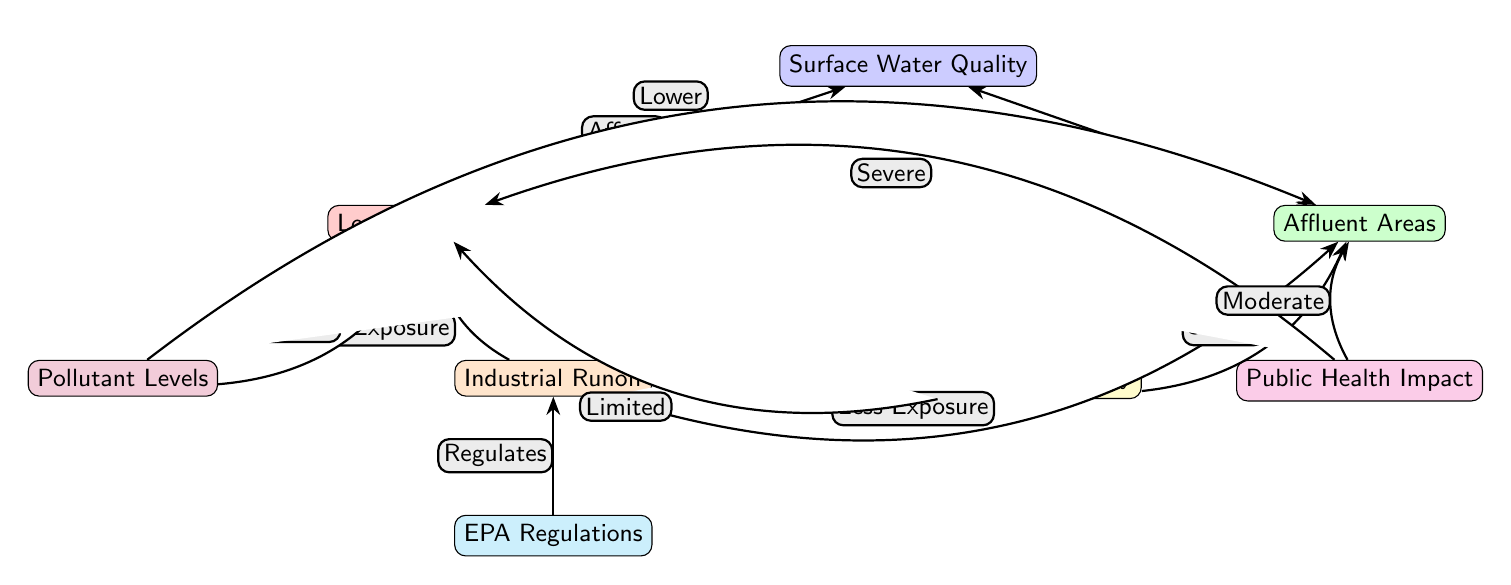What affects surface water quality in low-income areas? The node "Low-Income Areas" has a direct edge labeled "Affects" pointing to "Surface Water Quality". Therefore, it indicates that factors related to low-income areas significantly influence the quality of surface water.
Answer: Low-Income Areas What is the public health impact in affluent areas? The node "Public Health Impact" has an edge leading from "Affluent Areas". The label indicates that the impact is moderate in affluent areas, as represented in the flow of the diagram.
Answer: Moderate How many nodes are there in the diagram? Counting all the distinct labeled nodes in the diagram including "Surface Water Quality," "Low-Income Areas," "Affluent Areas," "Industrial Runoff," "Pollutant Levels," "Community Advocacy," "EPA Regulations," and "Public Health Impact" gives a total of 8 nodes.
Answer: 8 What is the relationship between industrial runoff and low-income areas? The edge between "Industrial Runoff" and "Low-Income Areas" is labeled "More Exposure," which shows that industrial runoff increases exposure to pollutants in low-income areas.
Answer: More Exposure How does community advocacy affect affluent areas? The diagram shows an edge from "Community Advocacy" to "Affluent Areas" with a label "Strong." This indicates that community advocacy significantly enhances the environmental conditions in affluent areas.
Answer: Strong What regulates industrial runoff? The node "EPA Regulations" has a direct edge labeled "Regulates" pointing to "Industrial Runoff," meaning that EPA regulations directly affect the levels of industrial runoff.
Answer: EPA Regulations What type of pollutant levels exist in low-income areas? The diagram indicates through the edge labeled "Higher" from "Pollutant Levels" to "Low-Income Areas" that pollutant levels are higher in these regions.
Answer: Higher What is the public health impact in low-income areas? The edge between "Public Health Impact" and "Low-Income Areas" indicates a severe impact, showing that low-income communities experience significant public health challenges due to poorer water quality.
Answer: Severe 